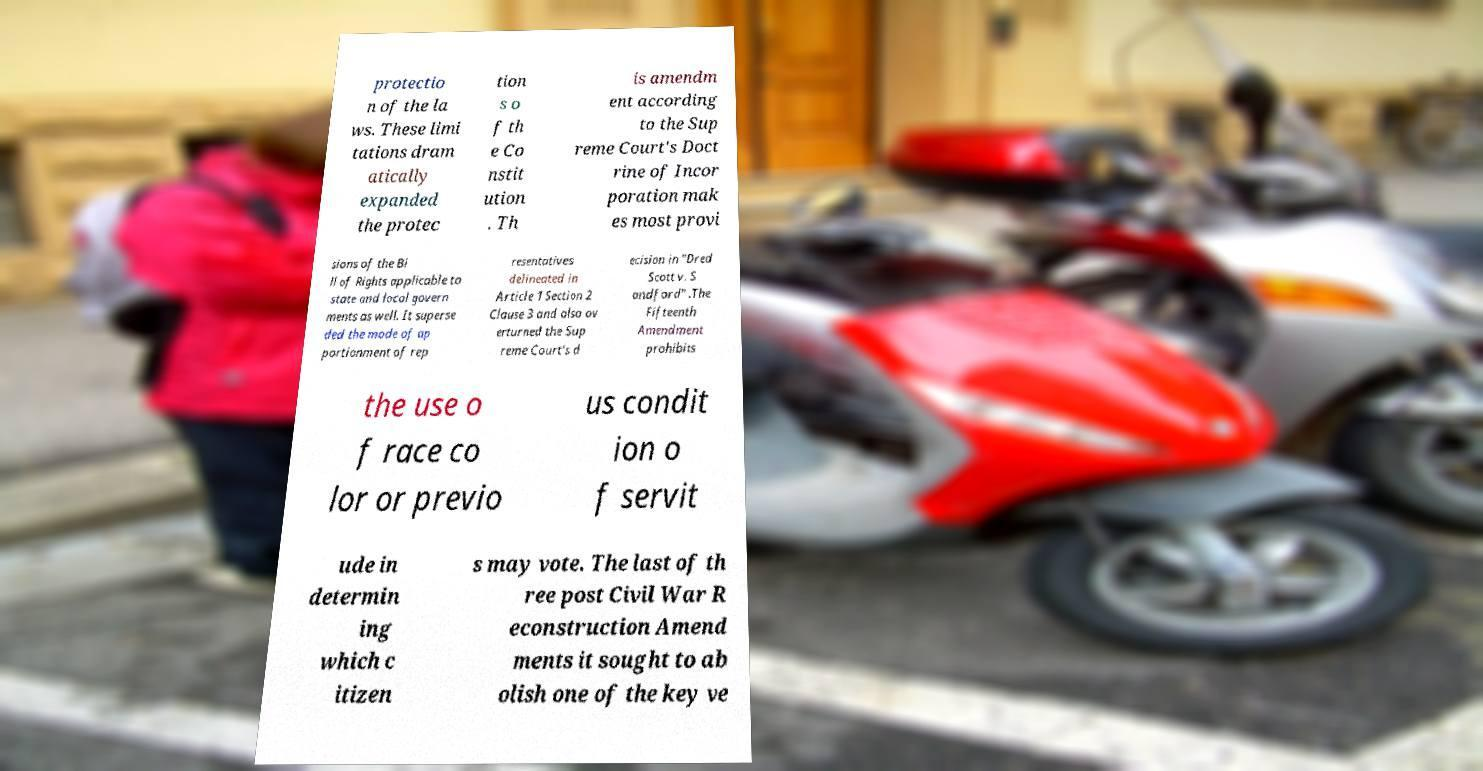There's text embedded in this image that I need extracted. Can you transcribe it verbatim? protectio n of the la ws. These limi tations dram atically expanded the protec tion s o f th e Co nstit ution . Th is amendm ent according to the Sup reme Court's Doct rine of Incor poration mak es most provi sions of the Bi ll of Rights applicable to state and local govern ments as well. It superse ded the mode of ap portionment of rep resentatives delineated in Article 1 Section 2 Clause 3 and also ov erturned the Sup reme Court's d ecision in "Dred Scott v. S andford" .The Fifteenth Amendment prohibits the use o f race co lor or previo us condit ion o f servit ude in determin ing which c itizen s may vote. The last of th ree post Civil War R econstruction Amend ments it sought to ab olish one of the key ve 